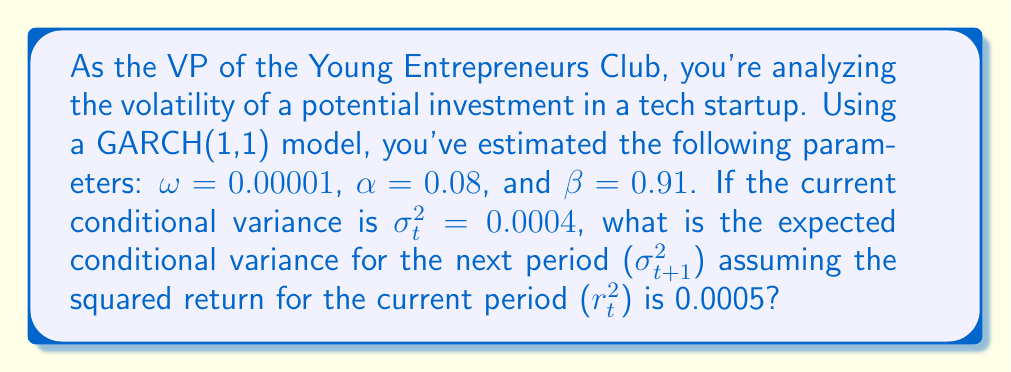What is the answer to this math problem? To solve this problem, we need to use the GARCH(1,1) model equation:

$$\sigma_{t+1}^2 = \omega + \alpha r_t^2 + \beta \sigma_t^2$$

Where:
$\sigma_{t+1}^2$ is the conditional variance for the next period
$\omega$ is the long-term average variance rate
$\alpha$ is the weight assigned to the most recent squared return
$\beta$ is the weight assigned to the previous period's variance
$r_t^2$ is the squared return for the current period
$\sigma_t^2$ is the current conditional variance

Let's substitute the given values into the equation:

$\omega = 0.00001$
$\alpha = 0.08$
$\beta = 0.91$
$r_t^2 = 0.0005$
$\sigma_t^2 = 0.0004$

Now, let's calculate:

$$\begin{align}
\sigma_{t+1}^2 &= 0.00001 + 0.08 \times 0.0005 + 0.91 \times 0.0004 \\
&= 0.00001 + 0.00004 + 0.000364 \\
&= 0.000414
\end{align}$$

This result represents the expected conditional variance for the next period, which is a measure of the volatility we can expect in the investment's returns.
Answer: $\sigma_{t+1}^2 = 0.000414$ 